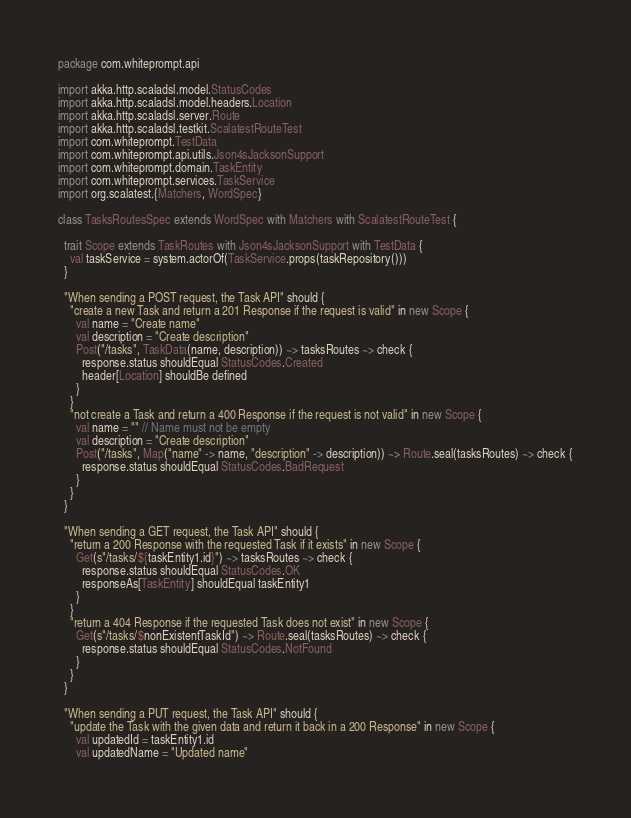Convert code to text. <code><loc_0><loc_0><loc_500><loc_500><_Scala_>package com.whiteprompt.api

import akka.http.scaladsl.model.StatusCodes
import akka.http.scaladsl.model.headers.Location
import akka.http.scaladsl.server.Route
import akka.http.scaladsl.testkit.ScalatestRouteTest
import com.whiteprompt.TestData
import com.whiteprompt.api.utils.Json4sJacksonSupport
import com.whiteprompt.domain.TaskEntity
import com.whiteprompt.services.TaskService
import org.scalatest.{Matchers, WordSpec}

class TasksRoutesSpec extends WordSpec with Matchers with ScalatestRouteTest {

  trait Scope extends TaskRoutes with Json4sJacksonSupport with TestData {
    val taskService = system.actorOf(TaskService.props(taskRepository()))
  }

  "When sending a POST request, the Task API" should {
    "create a new Task and return a 201 Response if the request is valid" in new Scope {
      val name = "Create name"
      val description = "Create description"
      Post("/tasks", TaskData(name, description)) ~> tasksRoutes ~> check {
        response.status shouldEqual StatusCodes.Created
        header[Location] shouldBe defined
      }
    }
    "not create a Task and return a 400 Response if the request is not valid" in new Scope {
      val name = "" // Name must not be empty
      val description = "Create description"
      Post("/tasks", Map("name" -> name, "description" -> description)) ~> Route.seal(tasksRoutes) ~> check {
        response.status shouldEqual StatusCodes.BadRequest
      }
    }
  }

  "When sending a GET request, the Task API" should {
    "return a 200 Response with the requested Task if it exists" in new Scope {
      Get(s"/tasks/${taskEntity1.id}") ~> tasksRoutes ~> check {
        response.status shouldEqual StatusCodes.OK
        responseAs[TaskEntity] shouldEqual taskEntity1
      }
    }
    "return a 404 Response if the requested Task does not exist" in new Scope {
      Get(s"/tasks/$nonExistentTaskId") ~> Route.seal(tasksRoutes) ~> check {
        response.status shouldEqual StatusCodes.NotFound
      }
    }
  }

  "When sending a PUT request, the Task API" should {
    "update the Task with the given data and return it back in a 200 Response" in new Scope {
      val updatedId = taskEntity1.id
      val updatedName = "Updated name"</code> 